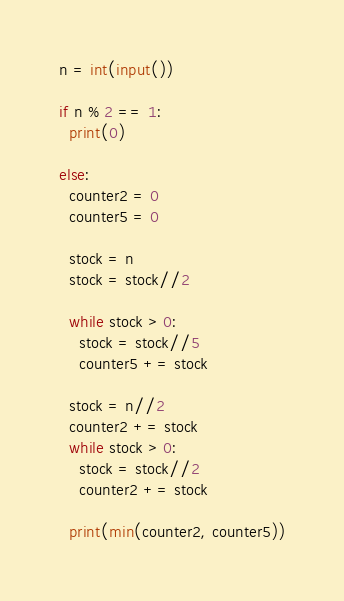Convert code to text. <code><loc_0><loc_0><loc_500><loc_500><_Python_>n = int(input())

if n % 2 == 1:
  print(0)

else:
  counter2 = 0
  counter5 = 0
  
  stock = n
  stock = stock//2
  
  while stock > 0:
    stock = stock//5
    counter5 += stock
    
  stock = n//2
  counter2 += stock
  while stock > 0:
    stock = stock//2
    counter2 += stock
    
  print(min(counter2, counter5))</code> 